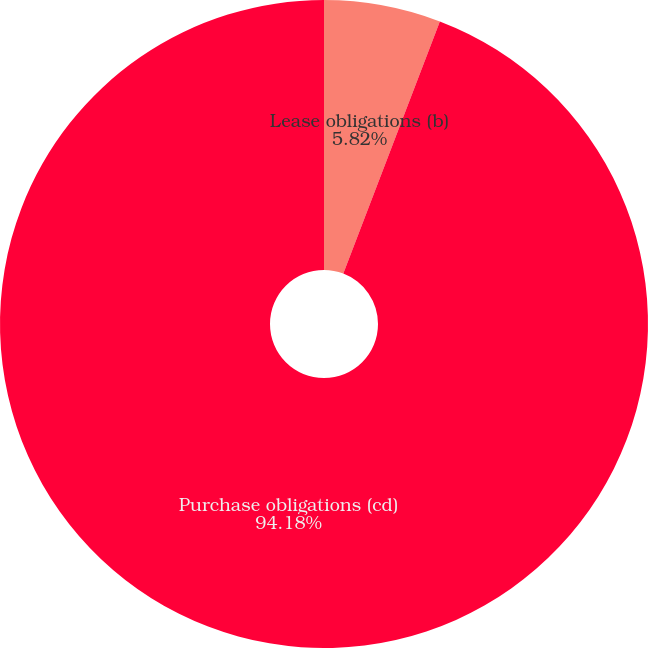Convert chart to OTSL. <chart><loc_0><loc_0><loc_500><loc_500><pie_chart><fcel>Lease obligations (b)<fcel>Purchase obligations (cd)<nl><fcel>5.82%<fcel>94.18%<nl></chart> 